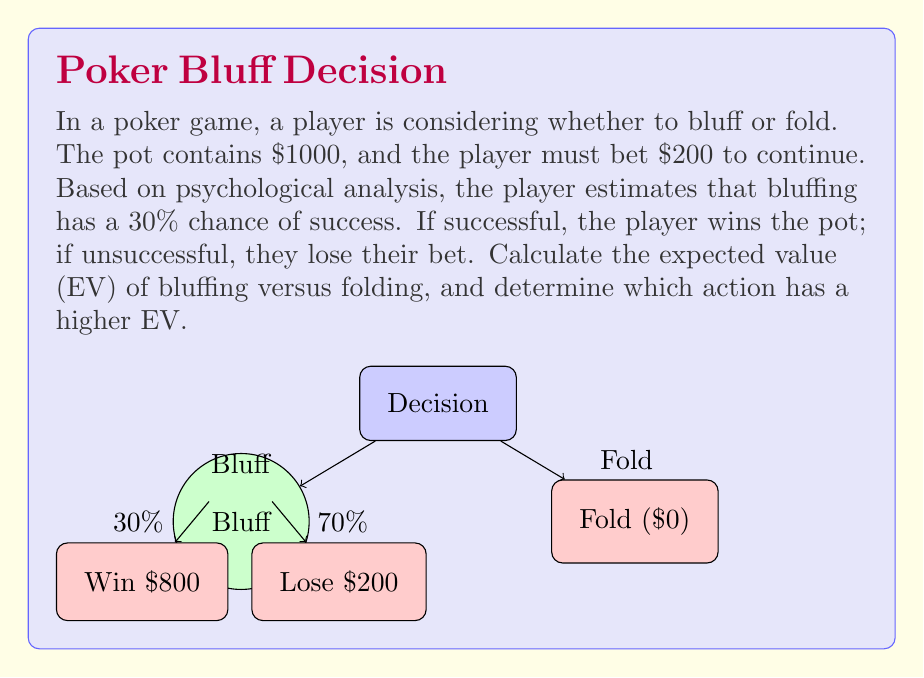Could you help me with this problem? Let's approach this step-by-step:

1) First, let's calculate the expected value of bluffing:

   a) If successful (30% chance):
      Gain = Pot size - Bet = $1000 - $200 = $800
   
   b) If unsuccessful (70% chance):
      Loss = Bet = $200

   Expected Value of Bluffing:
   $$EV_{bluff} = (0.30 \times 800) + (0.70 \times (-200))$$
   $$EV_{bluff} = 240 - 140 = $100$$

2) Now, let's calculate the expected value of folding:
   
   When folding, the player neither gains nor loses money.
   $$EV_{fold} = $0$$

3) Comparing the two expected values:
   
   $$EV_{bluff} = $100 > EV_{fold} = $0$$

4) Risk-Reward Ratio:
   
   The risk (potential loss) is $200, while the reward (potential gain) is $800.
   Risk-Reward Ratio = $200 : $800 = 1 : 4

Therefore, bluffing has a higher expected value in this situation, despite the psychological uncertainty about reading opponents' body language.
Answer: $EV_{bluff} = $100, EV_{fold} = $0; Bluffing has higher EV 